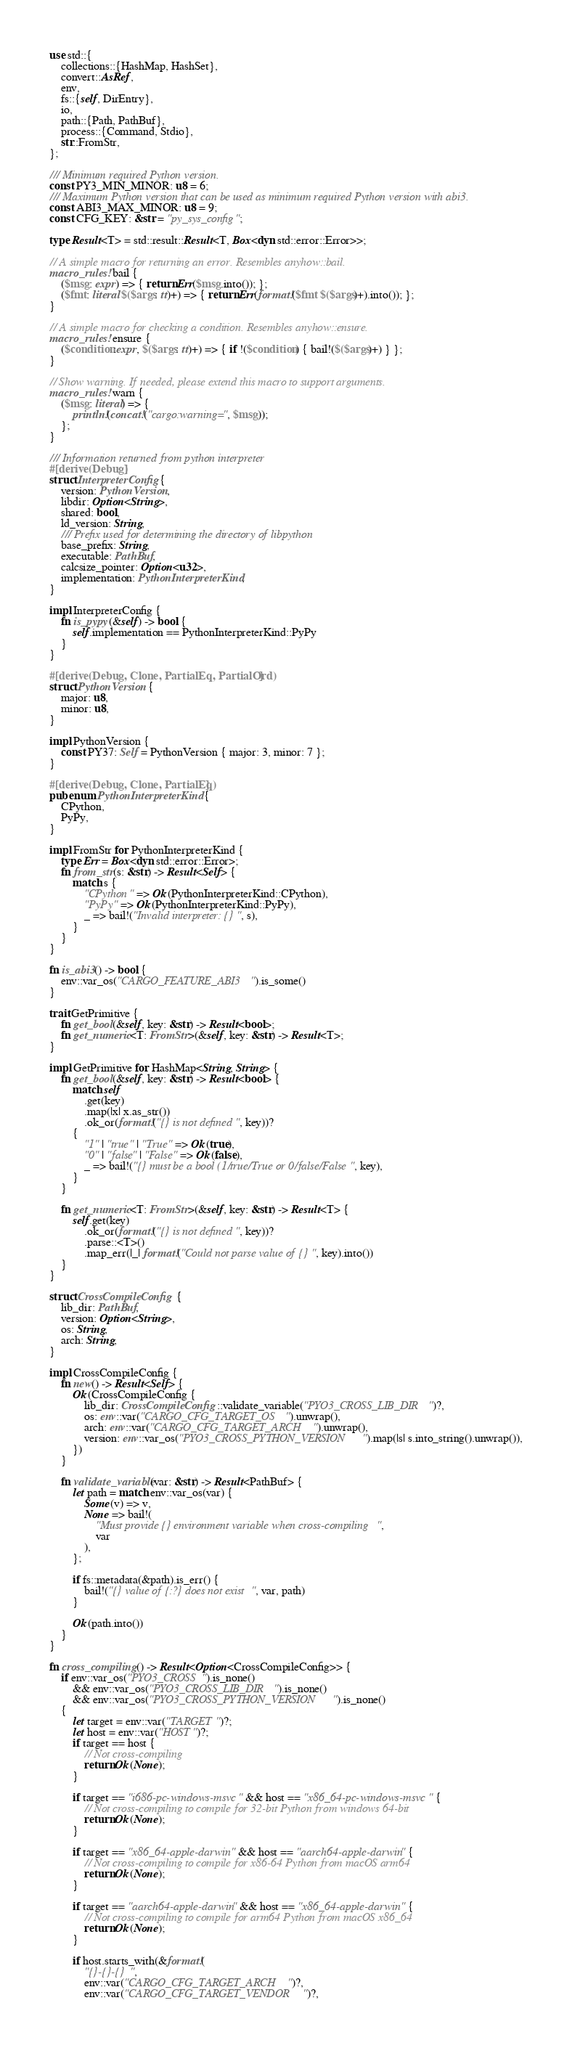<code> <loc_0><loc_0><loc_500><loc_500><_Rust_>use std::{
    collections::{HashMap, HashSet},
    convert::AsRef,
    env,
    fs::{self, DirEntry},
    io,
    path::{Path, PathBuf},
    process::{Command, Stdio},
    str::FromStr,
};

/// Minimum required Python version.
const PY3_MIN_MINOR: u8 = 6;
/// Maximum Python version that can be used as minimum required Python version with abi3.
const ABI3_MAX_MINOR: u8 = 9;
const CFG_KEY: &str = "py_sys_config";

type Result<T> = std::result::Result<T, Box<dyn std::error::Error>>;

// A simple macro for returning an error. Resembles anyhow::bail.
macro_rules! bail {
    ($msg: expr) => { return Err($msg.into()); };
    ($fmt: literal $($args: tt)+) => { return Err(format!($fmt $($args)+).into()); };
}

// A simple macro for checking a condition. Resembles anyhow::ensure.
macro_rules! ensure {
    ($condition:expr, $($args: tt)+) => { if !($condition) { bail!($($args)+) } };
}

// Show warning. If needed, please extend this macro to support arguments.
macro_rules! warn {
    ($msg: literal) => {
        println!(concat!("cargo:warning=", $msg));
    };
}

/// Information returned from python interpreter
#[derive(Debug)]
struct InterpreterConfig {
    version: PythonVersion,
    libdir: Option<String>,
    shared: bool,
    ld_version: String,
    /// Prefix used for determining the directory of libpython
    base_prefix: String,
    executable: PathBuf,
    calcsize_pointer: Option<u32>,
    implementation: PythonInterpreterKind,
}

impl InterpreterConfig {
    fn is_pypy(&self) -> bool {
        self.implementation == PythonInterpreterKind::PyPy
    }
}

#[derive(Debug, Clone, PartialEq, PartialOrd)]
struct PythonVersion {
    major: u8,
    minor: u8,
}

impl PythonVersion {
    const PY37: Self = PythonVersion { major: 3, minor: 7 };
}

#[derive(Debug, Clone, PartialEq)]
pub enum PythonInterpreterKind {
    CPython,
    PyPy,
}

impl FromStr for PythonInterpreterKind {
    type Err = Box<dyn std::error::Error>;
    fn from_str(s: &str) -> Result<Self> {
        match s {
            "CPython" => Ok(PythonInterpreterKind::CPython),
            "PyPy" => Ok(PythonInterpreterKind::PyPy),
            _ => bail!("Invalid interpreter: {}", s),
        }
    }
}

fn is_abi3() -> bool {
    env::var_os("CARGO_FEATURE_ABI3").is_some()
}

trait GetPrimitive {
    fn get_bool(&self, key: &str) -> Result<bool>;
    fn get_numeric<T: FromStr>(&self, key: &str) -> Result<T>;
}

impl GetPrimitive for HashMap<String, String> {
    fn get_bool(&self, key: &str) -> Result<bool> {
        match self
            .get(key)
            .map(|x| x.as_str())
            .ok_or(format!("{} is not defined", key))?
        {
            "1" | "true" | "True" => Ok(true),
            "0" | "false" | "False" => Ok(false),
            _ => bail!("{} must be a bool (1/true/True or 0/false/False", key),
        }
    }

    fn get_numeric<T: FromStr>(&self, key: &str) -> Result<T> {
        self.get(key)
            .ok_or(format!("{} is not defined", key))?
            .parse::<T>()
            .map_err(|_| format!("Could not parse value of {}", key).into())
    }
}

struct CrossCompileConfig {
    lib_dir: PathBuf,
    version: Option<String>,
    os: String,
    arch: String,
}

impl CrossCompileConfig {
    fn new() -> Result<Self> {
        Ok(CrossCompileConfig {
            lib_dir: CrossCompileConfig::validate_variable("PYO3_CROSS_LIB_DIR")?,
            os: env::var("CARGO_CFG_TARGET_OS").unwrap(),
            arch: env::var("CARGO_CFG_TARGET_ARCH").unwrap(),
            version: env::var_os("PYO3_CROSS_PYTHON_VERSION").map(|s| s.into_string().unwrap()),
        })
    }

    fn validate_variable(var: &str) -> Result<PathBuf> {
        let path = match env::var_os(var) {
            Some(v) => v,
            None => bail!(
                "Must provide {} environment variable when cross-compiling",
                var
            ),
        };

        if fs::metadata(&path).is_err() {
            bail!("{} value of {:?} does not exist", var, path)
        }

        Ok(path.into())
    }
}

fn cross_compiling() -> Result<Option<CrossCompileConfig>> {
    if env::var_os("PYO3_CROSS").is_none()
        && env::var_os("PYO3_CROSS_LIB_DIR").is_none()
        && env::var_os("PYO3_CROSS_PYTHON_VERSION").is_none()
    {
        let target = env::var("TARGET")?;
        let host = env::var("HOST")?;
        if target == host {
            // Not cross-compiling
            return Ok(None);
        }

        if target == "i686-pc-windows-msvc" && host == "x86_64-pc-windows-msvc" {
            // Not cross-compiling to compile for 32-bit Python from windows 64-bit
            return Ok(None);
        }

        if target == "x86_64-apple-darwin" && host == "aarch64-apple-darwin" {
            // Not cross-compiling to compile for x86-64 Python from macOS arm64
            return Ok(None);
        }

        if target == "aarch64-apple-darwin" && host == "x86_64-apple-darwin" {
            // Not cross-compiling to compile for arm64 Python from macOS x86_64
            return Ok(None);
        }

        if host.starts_with(&format!(
            "{}-{}-{}",
            env::var("CARGO_CFG_TARGET_ARCH")?,
            env::var("CARGO_CFG_TARGET_VENDOR")?,</code> 